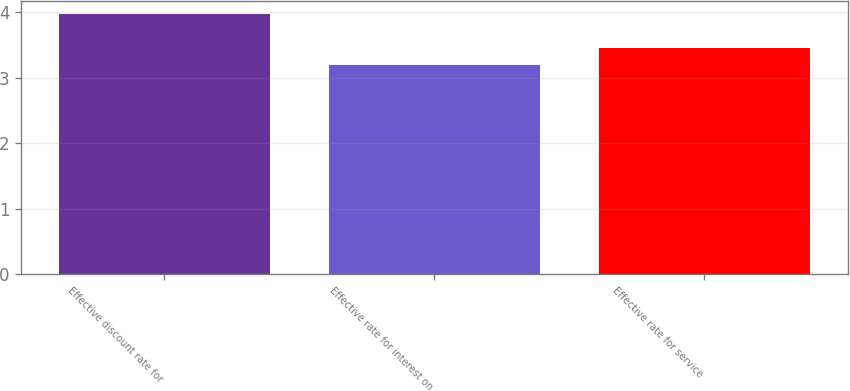<chart> <loc_0><loc_0><loc_500><loc_500><bar_chart><fcel>Effective discount rate for<fcel>Effective rate for interest on<fcel>Effective rate for service<nl><fcel>3.97<fcel>3.19<fcel>3.46<nl></chart> 